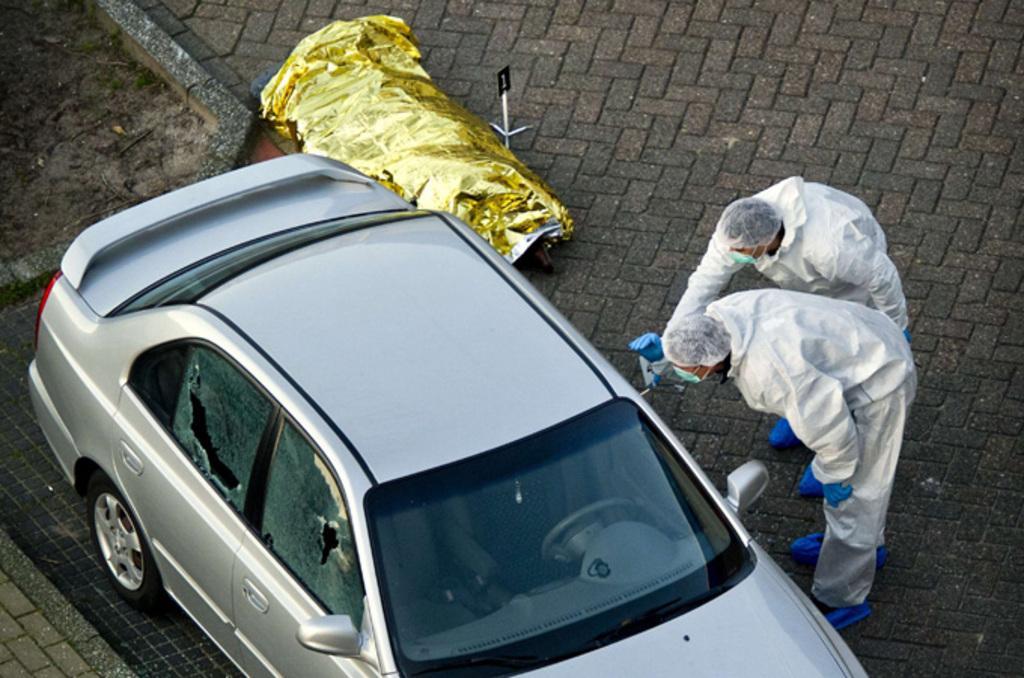Can you describe this image briefly? In this picture there is a silver color car parked on the cobbler stones. Beside there are two man wearing white dress looking to the car. Behind there is a golden color cover placed on the floor. 